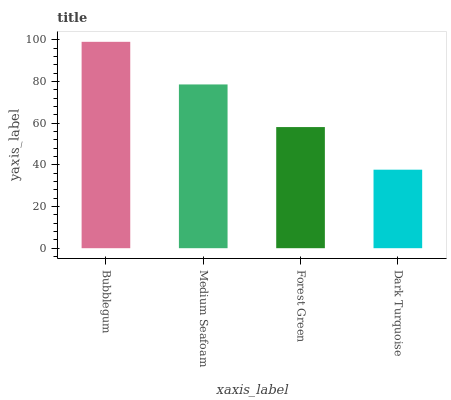Is Dark Turquoise the minimum?
Answer yes or no. Yes. Is Bubblegum the maximum?
Answer yes or no. Yes. Is Medium Seafoam the minimum?
Answer yes or no. No. Is Medium Seafoam the maximum?
Answer yes or no. No. Is Bubblegum greater than Medium Seafoam?
Answer yes or no. Yes. Is Medium Seafoam less than Bubblegum?
Answer yes or no. Yes. Is Medium Seafoam greater than Bubblegum?
Answer yes or no. No. Is Bubblegum less than Medium Seafoam?
Answer yes or no. No. Is Medium Seafoam the high median?
Answer yes or no. Yes. Is Forest Green the low median?
Answer yes or no. Yes. Is Bubblegum the high median?
Answer yes or no. No. Is Bubblegum the low median?
Answer yes or no. No. 